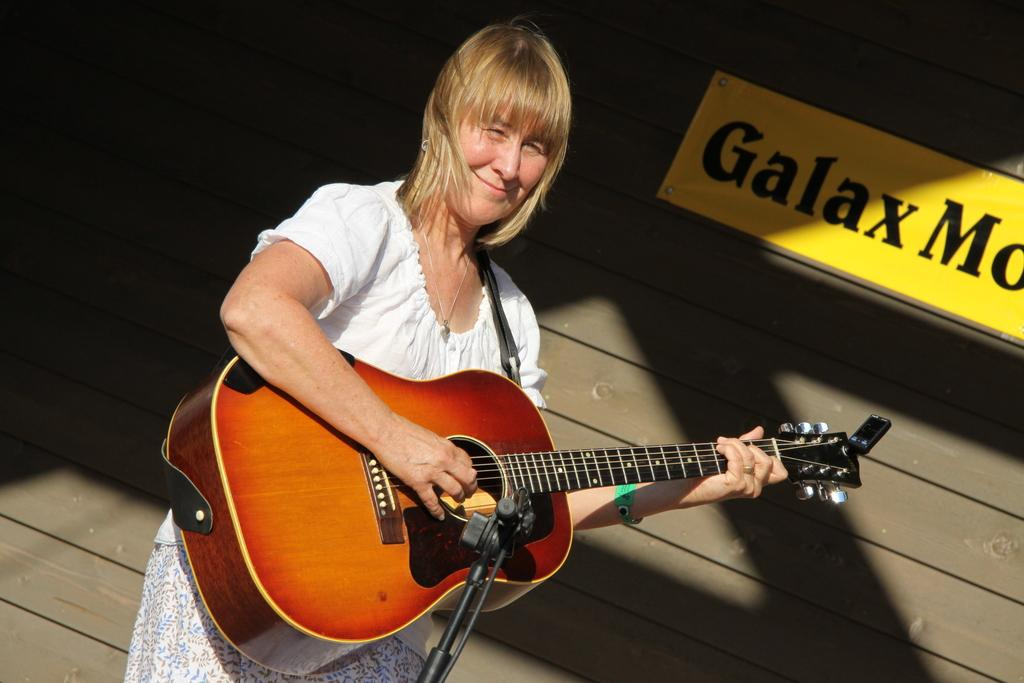What is the woman in the image doing? The woman is playing a guitar in the image. What is in front of the woman? There is a stand in front of the woman. What can be seen in the background of the image? There is a board and a wooden wall in the background of the image. How many dogs are present in the image? There are no dogs visible in the image. What does the woman feel regret about in the image? There is no indication of regret in the image; the woman is playing a guitar. 